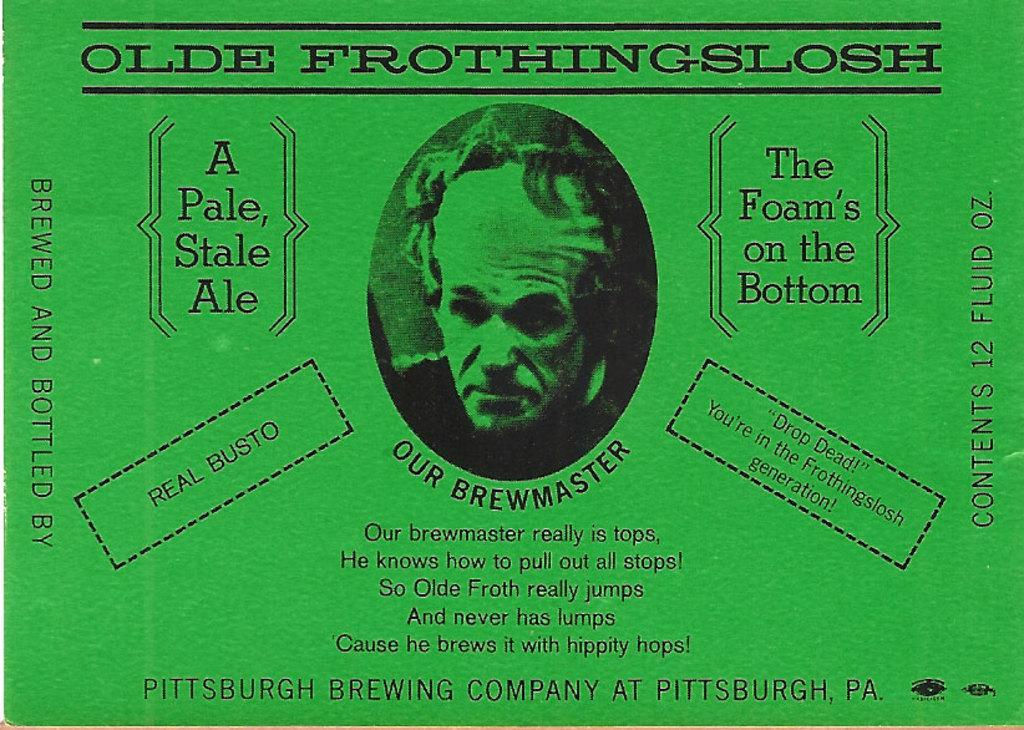Can you describe this image briefly? In this image there is a picture of a person as we can see in middle of this image and there is some text written around to this image. 